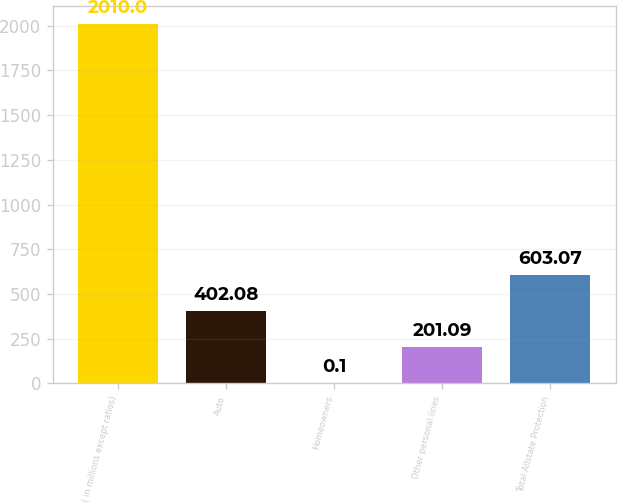<chart> <loc_0><loc_0><loc_500><loc_500><bar_chart><fcel>( in millions except ratios)<fcel>Auto<fcel>Homeowners<fcel>Other personal lines<fcel>Total Allstate Protection<nl><fcel>2010<fcel>402.08<fcel>0.1<fcel>201.09<fcel>603.07<nl></chart> 